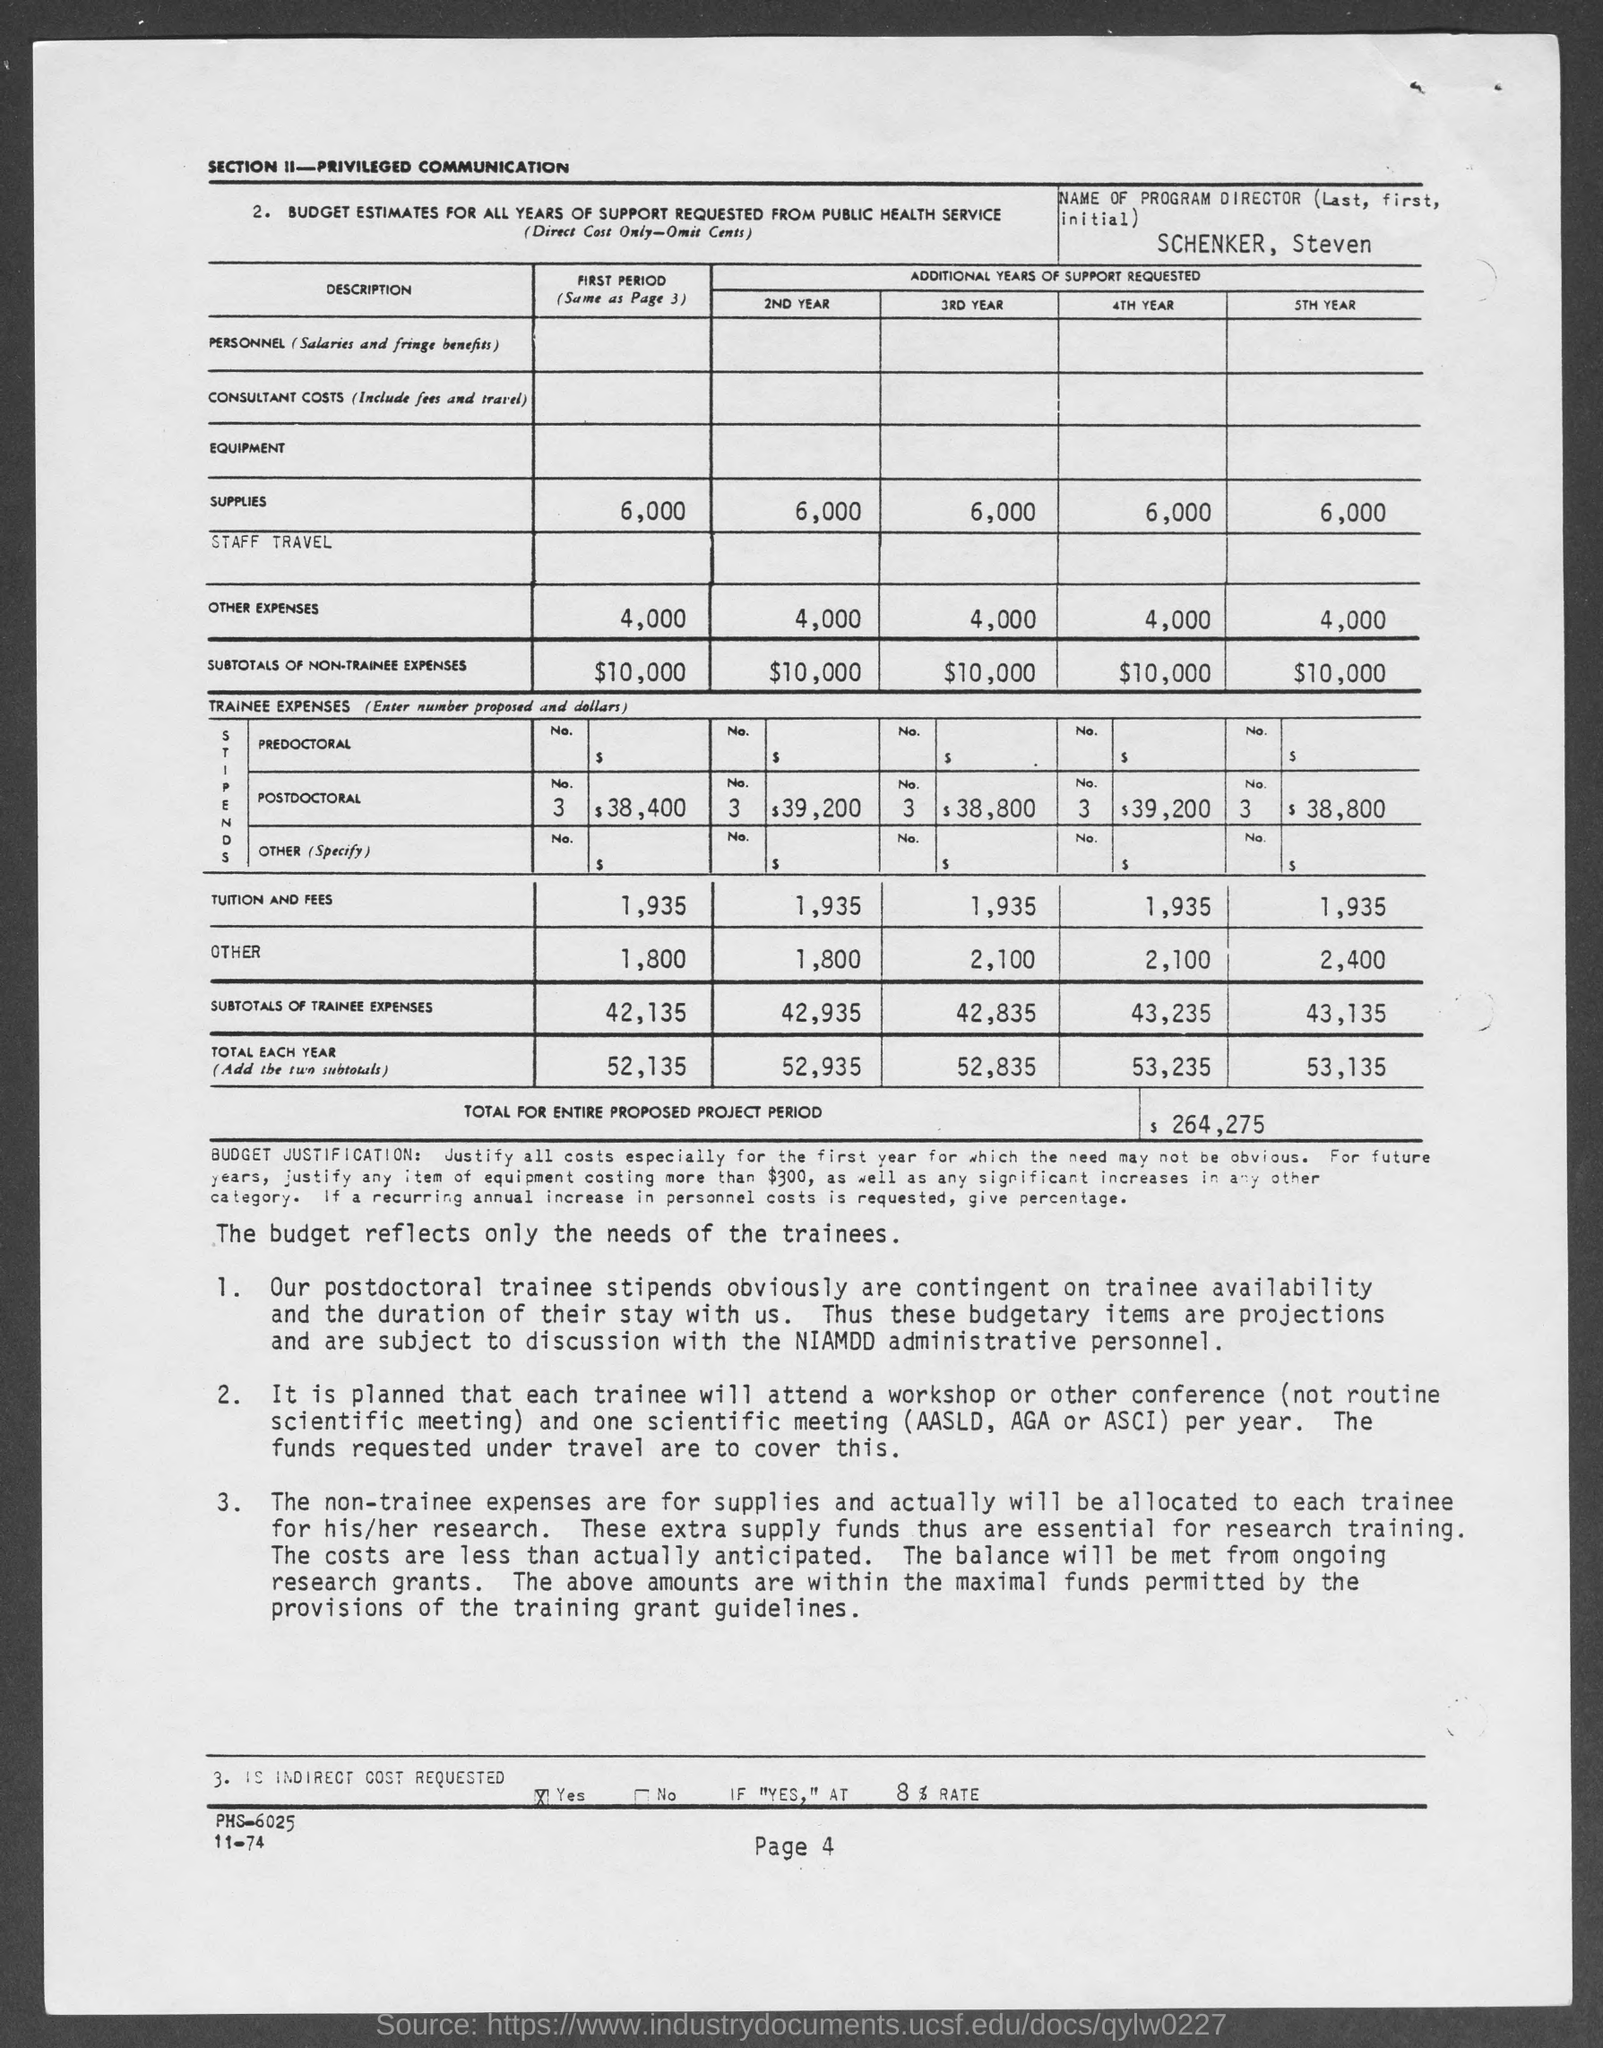Outline some significant characteristics in this image. The total amount for the entire proposed project period is $264,275. The subtotal of non-trainee expenses in the second year is $10,000. In the fourth year, the subtotal of non-trainee expenses was $10,000. The subtotal of non-trainee expenses in the fifth year is $10,000. The page number at the bottom of the page is 4. 